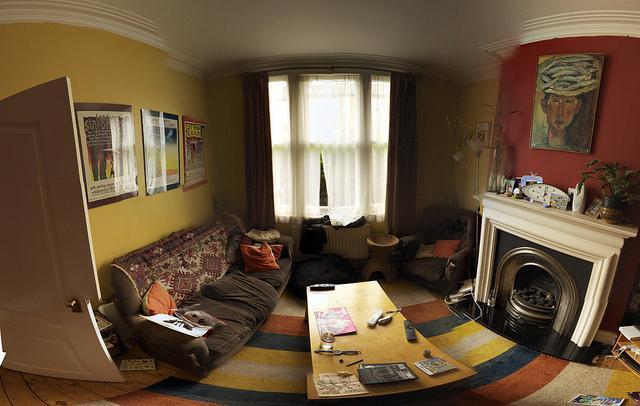How many tables are in the picture?
Give a very brief answer. 1. 